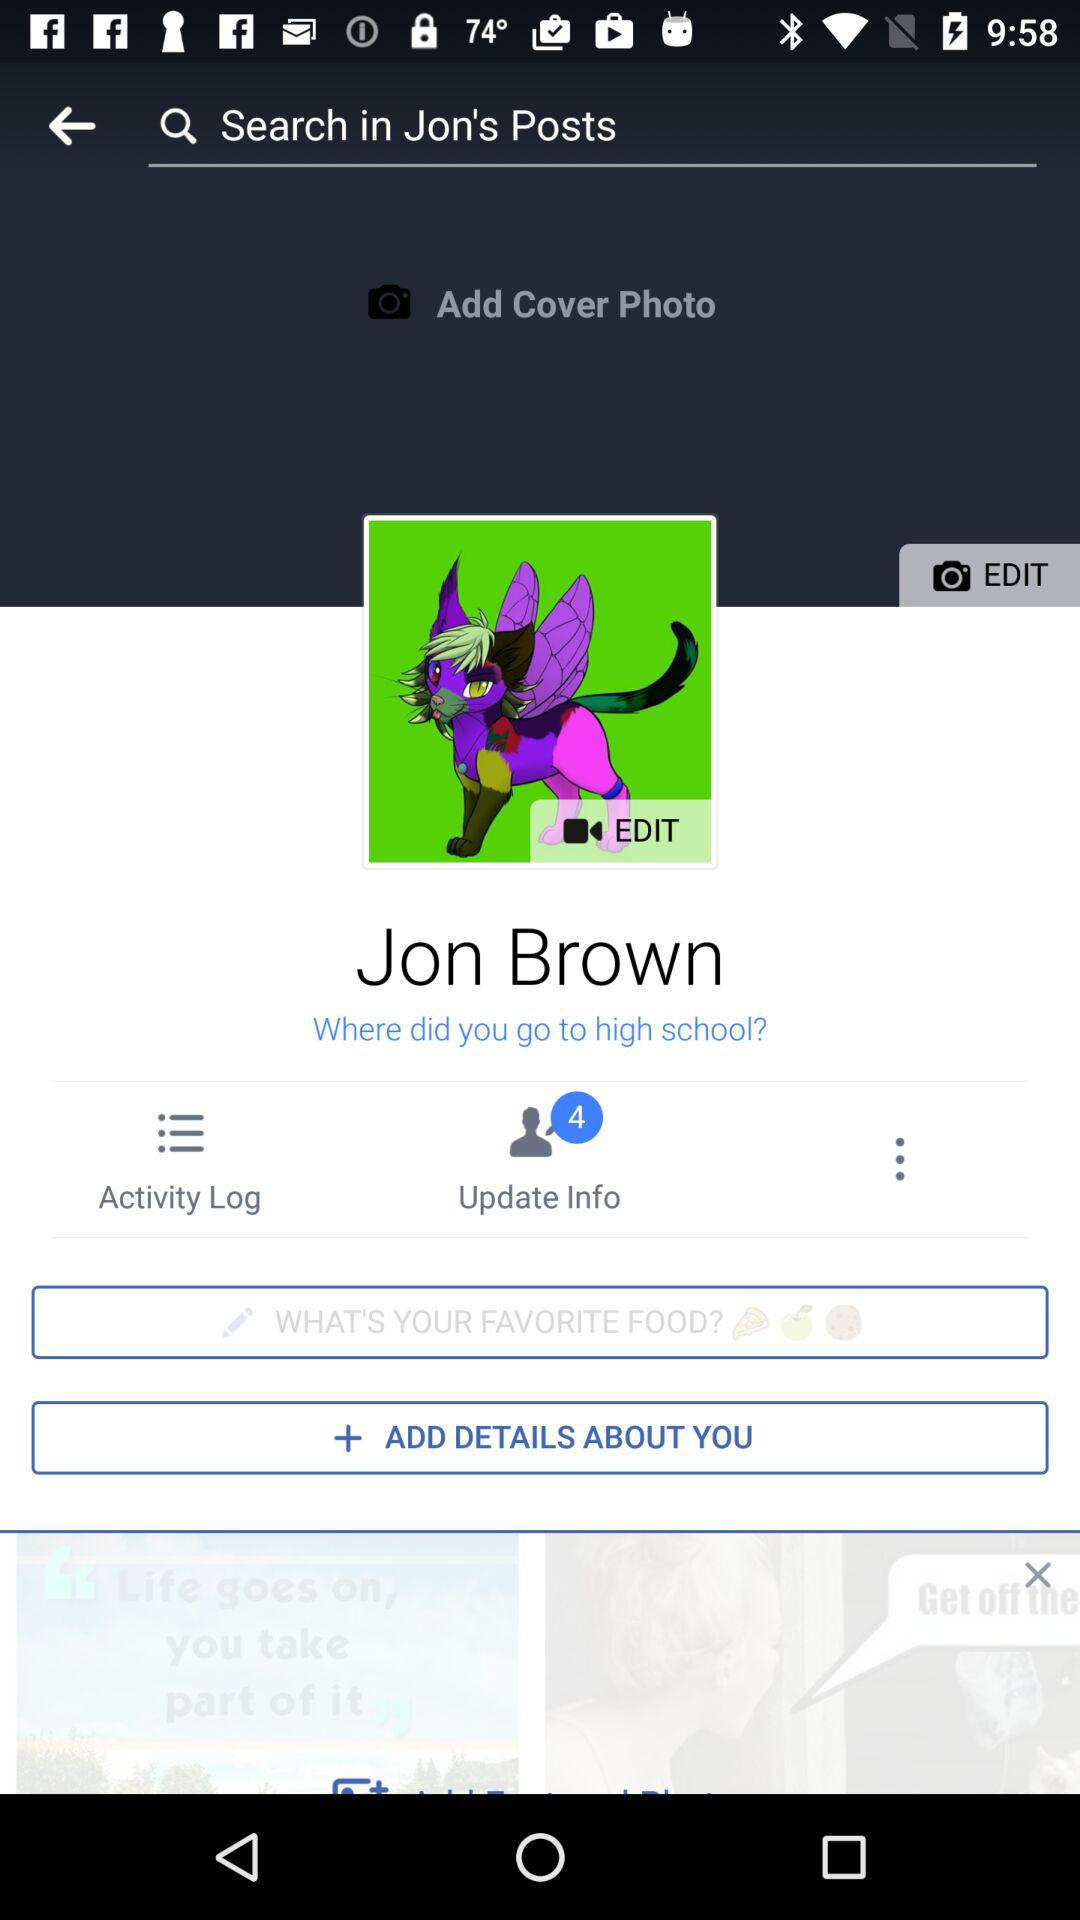What is the user name? The user name is Jon Brown. 